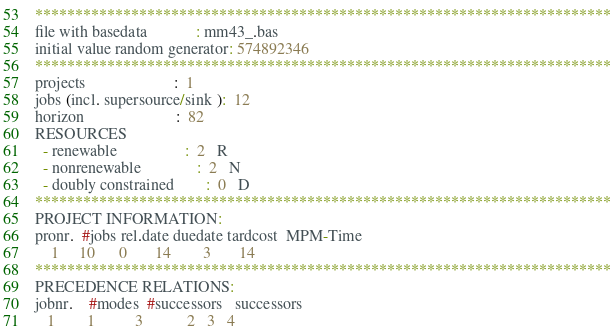<code> <loc_0><loc_0><loc_500><loc_500><_ObjectiveC_>************************************************************************
file with basedata            : mm43_.bas
initial value random generator: 574892346
************************************************************************
projects                      :  1
jobs (incl. supersource/sink ):  12
horizon                       :  82
RESOURCES
  - renewable                 :  2   R
  - nonrenewable              :  2   N
  - doubly constrained        :  0   D
************************************************************************
PROJECT INFORMATION:
pronr.  #jobs rel.date duedate tardcost  MPM-Time
    1     10      0       14        3       14
************************************************************************
PRECEDENCE RELATIONS:
jobnr.    #modes  #successors   successors
   1        1          3           2   3   4</code> 